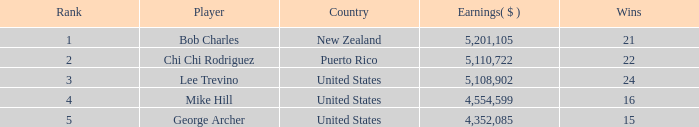Overall, what was the total earnings of the united states player george archer for victories less than 24 and a ranking above 5? 0.0. 